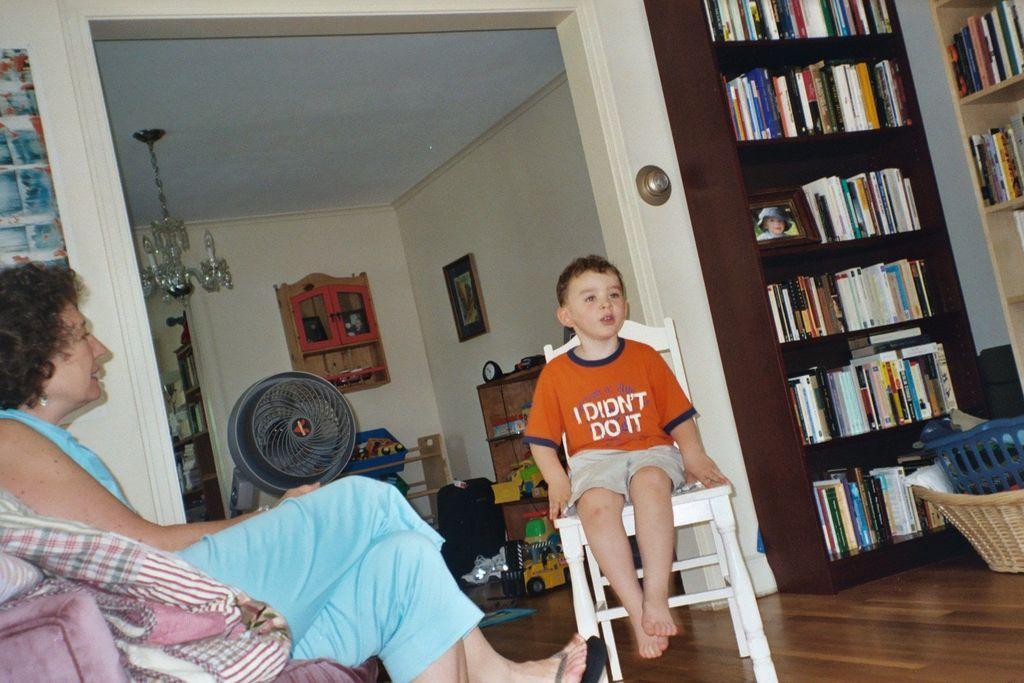Can you describe this image briefly? in this image one woman and boy is sitting on the chair and the the room has full of books,rack,toys and fan and some lights and table are there and the back ground is white. 